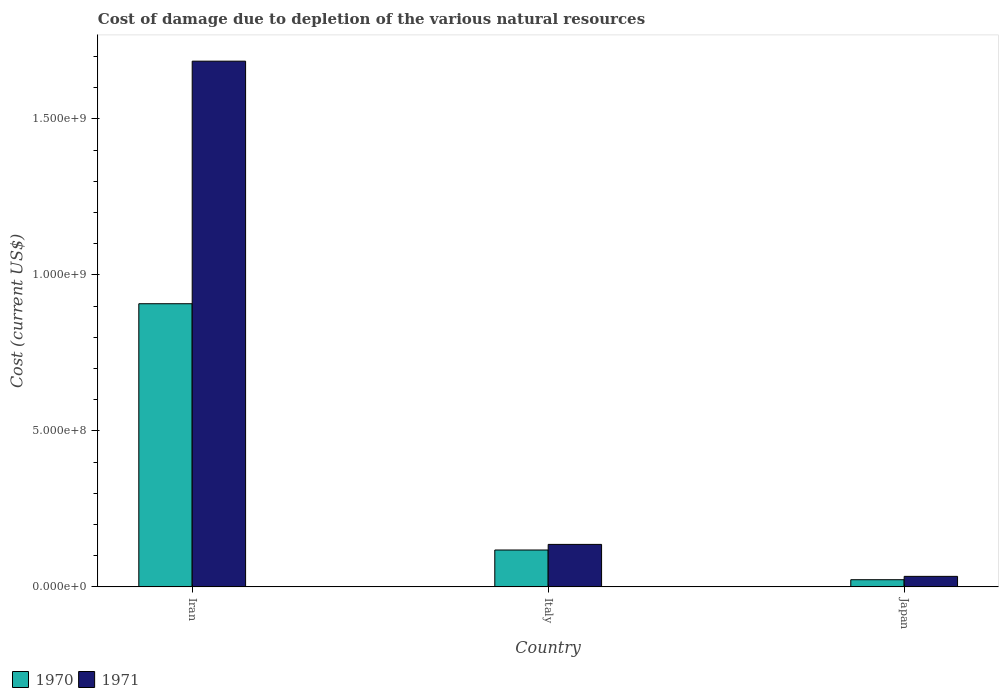How many different coloured bars are there?
Ensure brevity in your answer.  2. Are the number of bars per tick equal to the number of legend labels?
Offer a terse response. Yes. In how many cases, is the number of bars for a given country not equal to the number of legend labels?
Ensure brevity in your answer.  0. What is the cost of damage caused due to the depletion of various natural resources in 1970 in Italy?
Your answer should be very brief. 1.18e+08. Across all countries, what is the maximum cost of damage caused due to the depletion of various natural resources in 1971?
Offer a terse response. 1.69e+09. Across all countries, what is the minimum cost of damage caused due to the depletion of various natural resources in 1971?
Provide a succinct answer. 3.37e+07. In which country was the cost of damage caused due to the depletion of various natural resources in 1971 maximum?
Offer a very short reply. Iran. What is the total cost of damage caused due to the depletion of various natural resources in 1970 in the graph?
Offer a very short reply. 1.05e+09. What is the difference between the cost of damage caused due to the depletion of various natural resources in 1971 in Italy and that in Japan?
Your response must be concise. 1.02e+08. What is the difference between the cost of damage caused due to the depletion of various natural resources in 1971 in Iran and the cost of damage caused due to the depletion of various natural resources in 1970 in Japan?
Your answer should be compact. 1.66e+09. What is the average cost of damage caused due to the depletion of various natural resources in 1970 per country?
Your response must be concise. 3.50e+08. What is the difference between the cost of damage caused due to the depletion of various natural resources of/in 1971 and cost of damage caused due to the depletion of various natural resources of/in 1970 in Japan?
Offer a very short reply. 1.07e+07. What is the ratio of the cost of damage caused due to the depletion of various natural resources in 1971 in Italy to that in Japan?
Provide a succinct answer. 4.04. Is the difference between the cost of damage caused due to the depletion of various natural resources in 1971 in Iran and Italy greater than the difference between the cost of damage caused due to the depletion of various natural resources in 1970 in Iran and Italy?
Provide a succinct answer. Yes. What is the difference between the highest and the second highest cost of damage caused due to the depletion of various natural resources in 1971?
Ensure brevity in your answer.  1.02e+08. What is the difference between the highest and the lowest cost of damage caused due to the depletion of various natural resources in 1970?
Give a very brief answer. 8.85e+08. Is the sum of the cost of damage caused due to the depletion of various natural resources in 1971 in Iran and Italy greater than the maximum cost of damage caused due to the depletion of various natural resources in 1970 across all countries?
Your answer should be compact. Yes. What does the 2nd bar from the left in Japan represents?
Provide a short and direct response. 1971. What does the 1st bar from the right in Japan represents?
Ensure brevity in your answer.  1971. Are all the bars in the graph horizontal?
Keep it short and to the point. No. How many countries are there in the graph?
Give a very brief answer. 3. Are the values on the major ticks of Y-axis written in scientific E-notation?
Keep it short and to the point. Yes. Does the graph contain any zero values?
Your answer should be compact. No. Where does the legend appear in the graph?
Ensure brevity in your answer.  Bottom left. How many legend labels are there?
Offer a terse response. 2. What is the title of the graph?
Your answer should be compact. Cost of damage due to depletion of the various natural resources. What is the label or title of the X-axis?
Ensure brevity in your answer.  Country. What is the label or title of the Y-axis?
Keep it short and to the point. Cost (current US$). What is the Cost (current US$) in 1970 in Iran?
Offer a terse response. 9.08e+08. What is the Cost (current US$) of 1971 in Iran?
Your answer should be compact. 1.69e+09. What is the Cost (current US$) in 1970 in Italy?
Provide a short and direct response. 1.18e+08. What is the Cost (current US$) of 1971 in Italy?
Ensure brevity in your answer.  1.36e+08. What is the Cost (current US$) of 1970 in Japan?
Ensure brevity in your answer.  2.30e+07. What is the Cost (current US$) of 1971 in Japan?
Offer a terse response. 3.37e+07. Across all countries, what is the maximum Cost (current US$) of 1970?
Offer a terse response. 9.08e+08. Across all countries, what is the maximum Cost (current US$) of 1971?
Keep it short and to the point. 1.69e+09. Across all countries, what is the minimum Cost (current US$) in 1970?
Make the answer very short. 2.30e+07. Across all countries, what is the minimum Cost (current US$) in 1971?
Provide a short and direct response. 3.37e+07. What is the total Cost (current US$) of 1970 in the graph?
Provide a short and direct response. 1.05e+09. What is the total Cost (current US$) of 1971 in the graph?
Provide a short and direct response. 1.86e+09. What is the difference between the Cost (current US$) of 1970 in Iran and that in Italy?
Your response must be concise. 7.89e+08. What is the difference between the Cost (current US$) in 1971 in Iran and that in Italy?
Ensure brevity in your answer.  1.55e+09. What is the difference between the Cost (current US$) in 1970 in Iran and that in Japan?
Your answer should be very brief. 8.85e+08. What is the difference between the Cost (current US$) of 1971 in Iran and that in Japan?
Offer a very short reply. 1.65e+09. What is the difference between the Cost (current US$) in 1970 in Italy and that in Japan?
Provide a succinct answer. 9.52e+07. What is the difference between the Cost (current US$) of 1971 in Italy and that in Japan?
Make the answer very short. 1.02e+08. What is the difference between the Cost (current US$) in 1970 in Iran and the Cost (current US$) in 1971 in Italy?
Your response must be concise. 7.71e+08. What is the difference between the Cost (current US$) of 1970 in Iran and the Cost (current US$) of 1971 in Japan?
Make the answer very short. 8.74e+08. What is the difference between the Cost (current US$) of 1970 in Italy and the Cost (current US$) of 1971 in Japan?
Provide a succinct answer. 8.45e+07. What is the average Cost (current US$) of 1970 per country?
Your response must be concise. 3.50e+08. What is the average Cost (current US$) in 1971 per country?
Keep it short and to the point. 6.18e+08. What is the difference between the Cost (current US$) of 1970 and Cost (current US$) of 1971 in Iran?
Ensure brevity in your answer.  -7.78e+08. What is the difference between the Cost (current US$) of 1970 and Cost (current US$) of 1971 in Italy?
Offer a very short reply. -1.80e+07. What is the difference between the Cost (current US$) in 1970 and Cost (current US$) in 1971 in Japan?
Provide a short and direct response. -1.07e+07. What is the ratio of the Cost (current US$) of 1970 in Iran to that in Italy?
Ensure brevity in your answer.  7.68. What is the ratio of the Cost (current US$) of 1971 in Iran to that in Italy?
Ensure brevity in your answer.  12.37. What is the ratio of the Cost (current US$) of 1970 in Iran to that in Japan?
Your response must be concise. 39.46. What is the ratio of the Cost (current US$) in 1971 in Iran to that in Japan?
Provide a succinct answer. 50. What is the ratio of the Cost (current US$) of 1970 in Italy to that in Japan?
Provide a short and direct response. 5.14. What is the ratio of the Cost (current US$) in 1971 in Italy to that in Japan?
Make the answer very short. 4.04. What is the difference between the highest and the second highest Cost (current US$) in 1970?
Provide a short and direct response. 7.89e+08. What is the difference between the highest and the second highest Cost (current US$) in 1971?
Keep it short and to the point. 1.55e+09. What is the difference between the highest and the lowest Cost (current US$) in 1970?
Offer a terse response. 8.85e+08. What is the difference between the highest and the lowest Cost (current US$) in 1971?
Provide a succinct answer. 1.65e+09. 